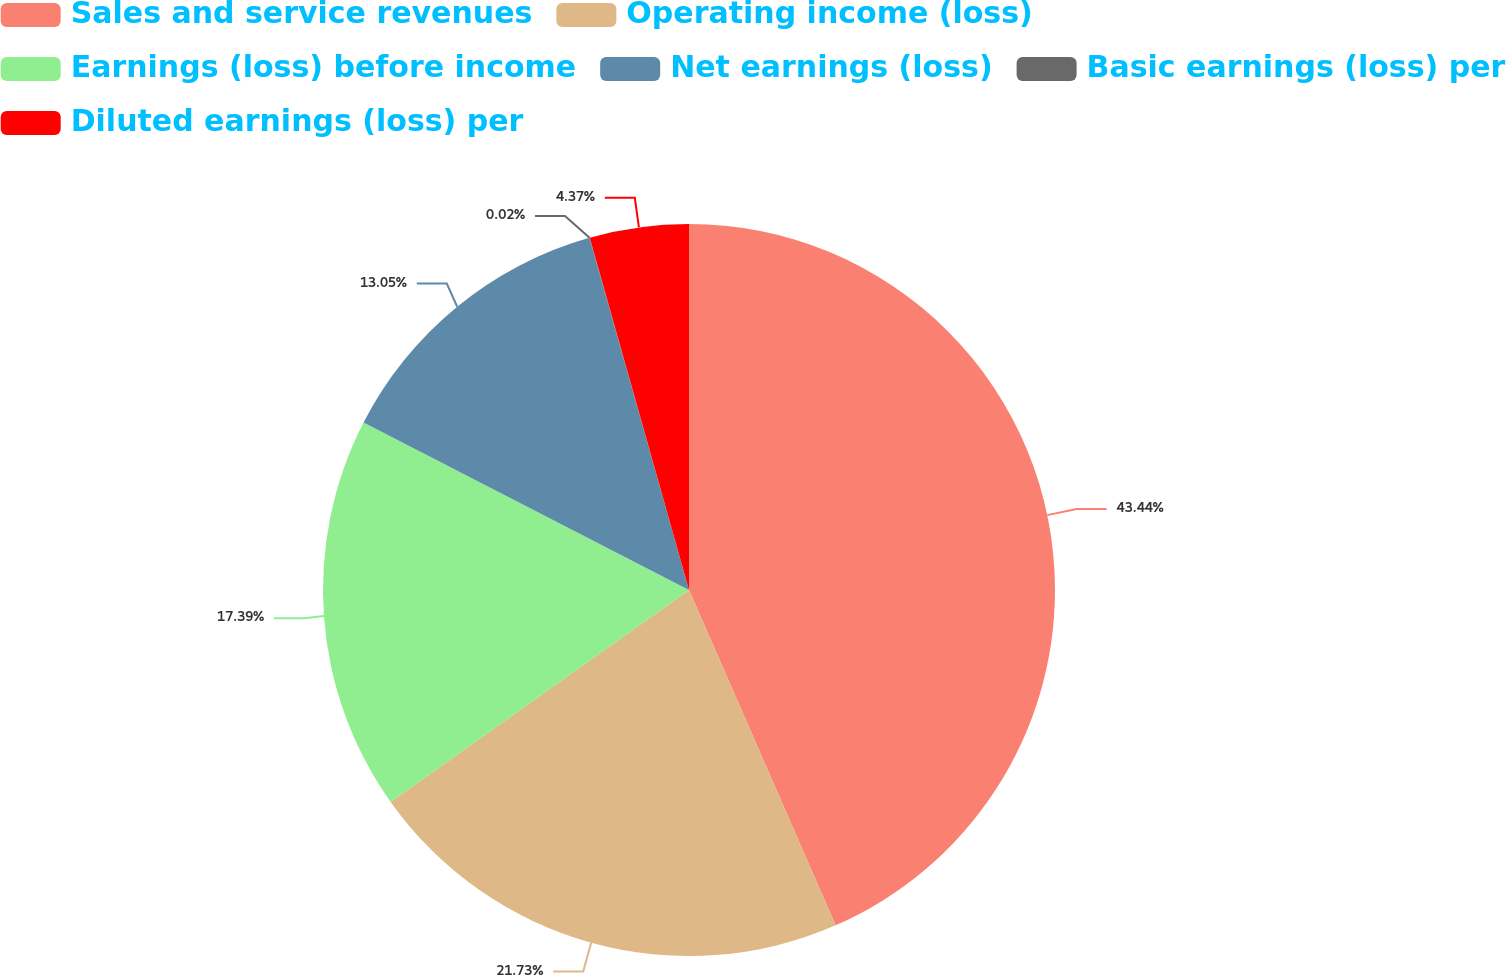<chart> <loc_0><loc_0><loc_500><loc_500><pie_chart><fcel>Sales and service revenues<fcel>Operating income (loss)<fcel>Earnings (loss) before income<fcel>Net earnings (loss)<fcel>Basic earnings (loss) per<fcel>Diluted earnings (loss) per<nl><fcel>43.44%<fcel>21.73%<fcel>17.39%<fcel>13.05%<fcel>0.02%<fcel>4.37%<nl></chart> 